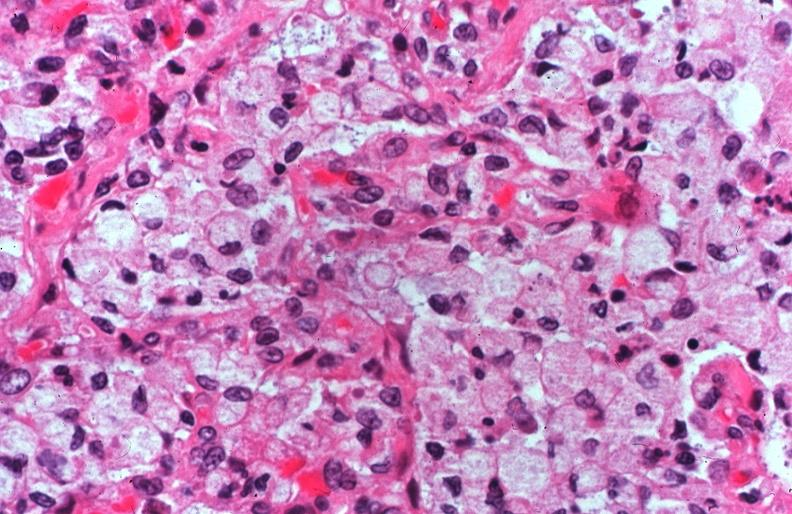s respiratory present?
Answer the question using a single word or phrase. Yes 